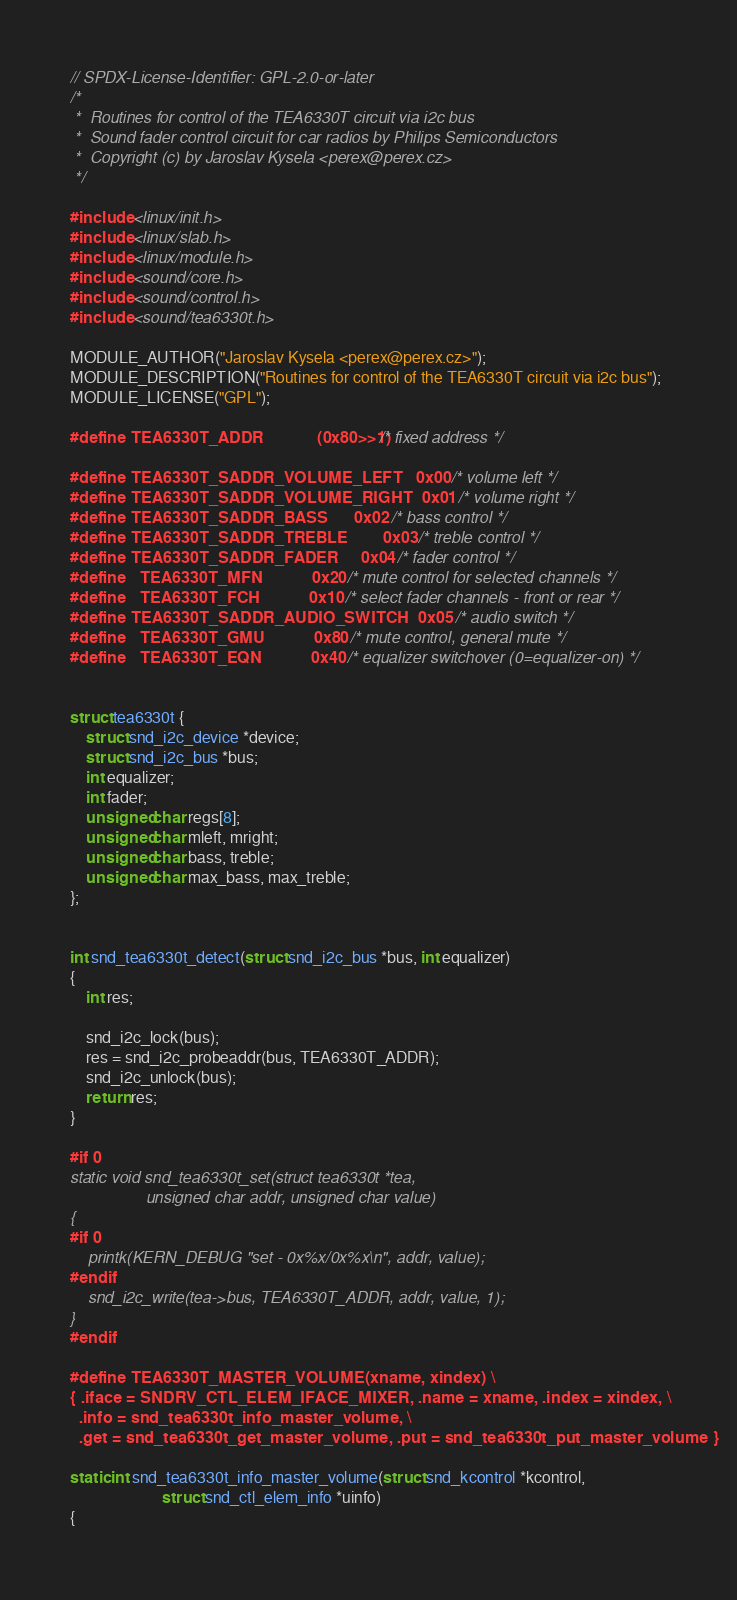<code> <loc_0><loc_0><loc_500><loc_500><_C_>// SPDX-License-Identifier: GPL-2.0-or-later
/*
 *  Routines for control of the TEA6330T circuit via i2c bus
 *  Sound fader control circuit for car radios by Philips Semiconductors
 *  Copyright (c) by Jaroslav Kysela <perex@perex.cz>
 */

#include <linux/init.h>
#include <linux/slab.h>
#include <linux/module.h>
#include <sound/core.h>
#include <sound/control.h>
#include <sound/tea6330t.h>

MODULE_AUTHOR("Jaroslav Kysela <perex@perex.cz>");
MODULE_DESCRIPTION("Routines for control of the TEA6330T circuit via i2c bus");
MODULE_LICENSE("GPL");

#define TEA6330T_ADDR			(0x80>>1) /* fixed address */

#define TEA6330T_SADDR_VOLUME_LEFT	0x00	/* volume left */
#define TEA6330T_SADDR_VOLUME_RIGHT	0x01	/* volume right */
#define TEA6330T_SADDR_BASS		0x02	/* bass control */
#define TEA6330T_SADDR_TREBLE		0x03	/* treble control */
#define TEA6330T_SADDR_FADER		0x04	/* fader control */
#define   TEA6330T_MFN			0x20	/* mute control for selected channels */
#define   TEA6330T_FCH			0x10	/* select fader channels - front or rear */
#define TEA6330T_SADDR_AUDIO_SWITCH	0x05	/* audio switch */
#define   TEA6330T_GMU			0x80	/* mute control, general mute */
#define   TEA6330T_EQN			0x40	/* equalizer switchover (0=equalizer-on) */


struct tea6330t {
	struct snd_i2c_device *device;
	struct snd_i2c_bus *bus;
	int equalizer;
	int fader;
	unsigned char regs[8];
	unsigned char mleft, mright;
	unsigned char bass, treble;
	unsigned char max_bass, max_treble;
};


int snd_tea6330t_detect(struct snd_i2c_bus *bus, int equalizer)
{
	int res;

	snd_i2c_lock(bus);
	res = snd_i2c_probeaddr(bus, TEA6330T_ADDR);
	snd_i2c_unlock(bus);
	return res;
}

#if 0
static void snd_tea6330t_set(struct tea6330t *tea,
			     unsigned char addr, unsigned char value)
{
#if 0
	printk(KERN_DEBUG "set - 0x%x/0x%x\n", addr, value);
#endif
	snd_i2c_write(tea->bus, TEA6330T_ADDR, addr, value, 1);
}
#endif

#define TEA6330T_MASTER_VOLUME(xname, xindex) \
{ .iface = SNDRV_CTL_ELEM_IFACE_MIXER, .name = xname, .index = xindex, \
  .info = snd_tea6330t_info_master_volume, \
  .get = snd_tea6330t_get_master_volume, .put = snd_tea6330t_put_master_volume }

static int snd_tea6330t_info_master_volume(struct snd_kcontrol *kcontrol,
					   struct snd_ctl_elem_info *uinfo)
{</code> 